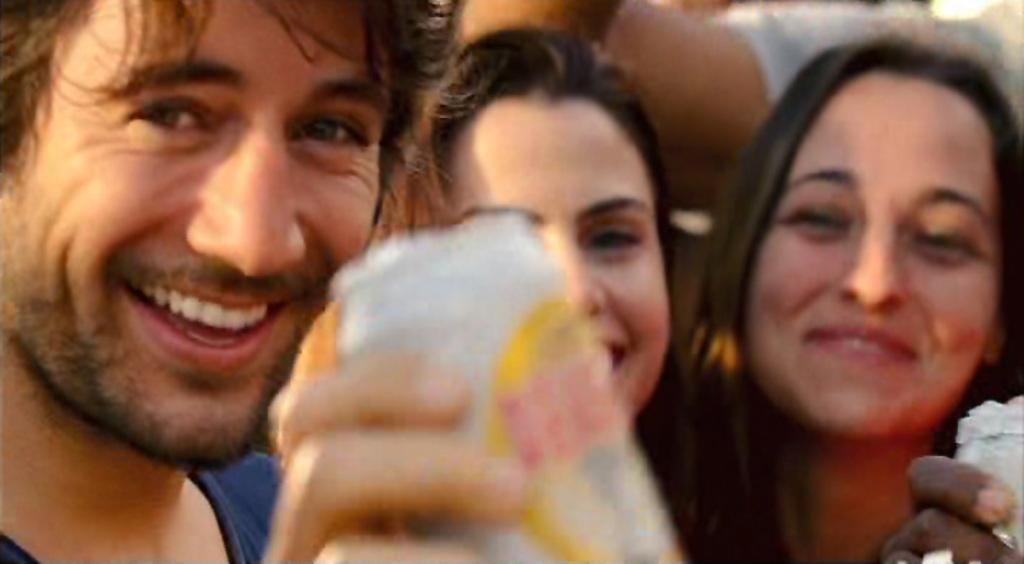How many people are in the image? There are three people in the image. What is the facial expression of the people in the image? The three people are smiling. Can you describe the actions of one of the people in the image? There is a person holding a can in the image. What type of pigs can be seen in the image? There are no pigs present in the image. Is the person holding the can the sister of the other two people in the image? The provided facts do not mention any relationships between the people in the image, so we cannot determine if the person holding the can is the sister of the other two people. 